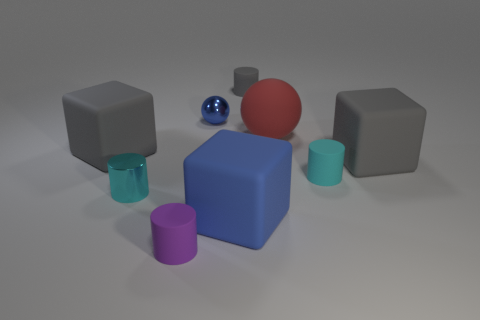Subtract 1 cylinders. How many cylinders are left? 3 Subtract all balls. How many objects are left? 7 Add 5 small gray objects. How many small gray objects exist? 6 Subtract 0 brown spheres. How many objects are left? 9 Subtract all small purple matte objects. Subtract all red matte cubes. How many objects are left? 8 Add 2 metal balls. How many metal balls are left? 3 